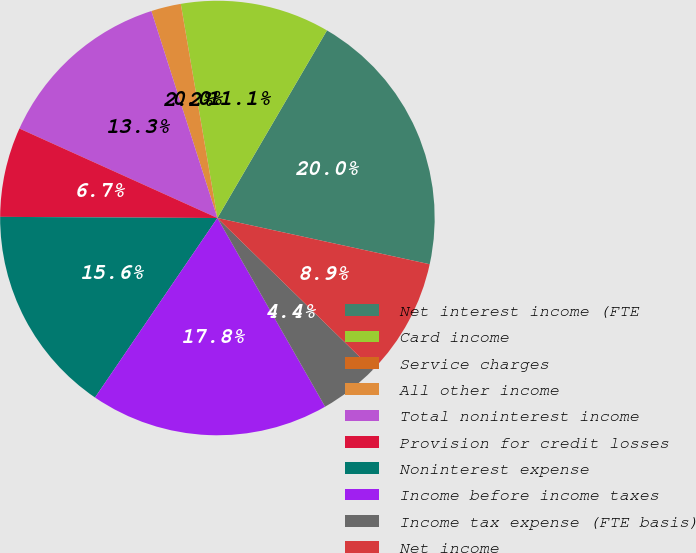Convert chart. <chart><loc_0><loc_0><loc_500><loc_500><pie_chart><fcel>Net interest income (FTE<fcel>Card income<fcel>Service charges<fcel>All other income<fcel>Total noninterest income<fcel>Provision for credit losses<fcel>Noninterest expense<fcel>Income before income taxes<fcel>Income tax expense (FTE basis)<fcel>Net income<nl><fcel>20.0%<fcel>11.11%<fcel>0.0%<fcel>2.22%<fcel>13.33%<fcel>6.67%<fcel>15.56%<fcel>17.78%<fcel>4.44%<fcel>8.89%<nl></chart> 